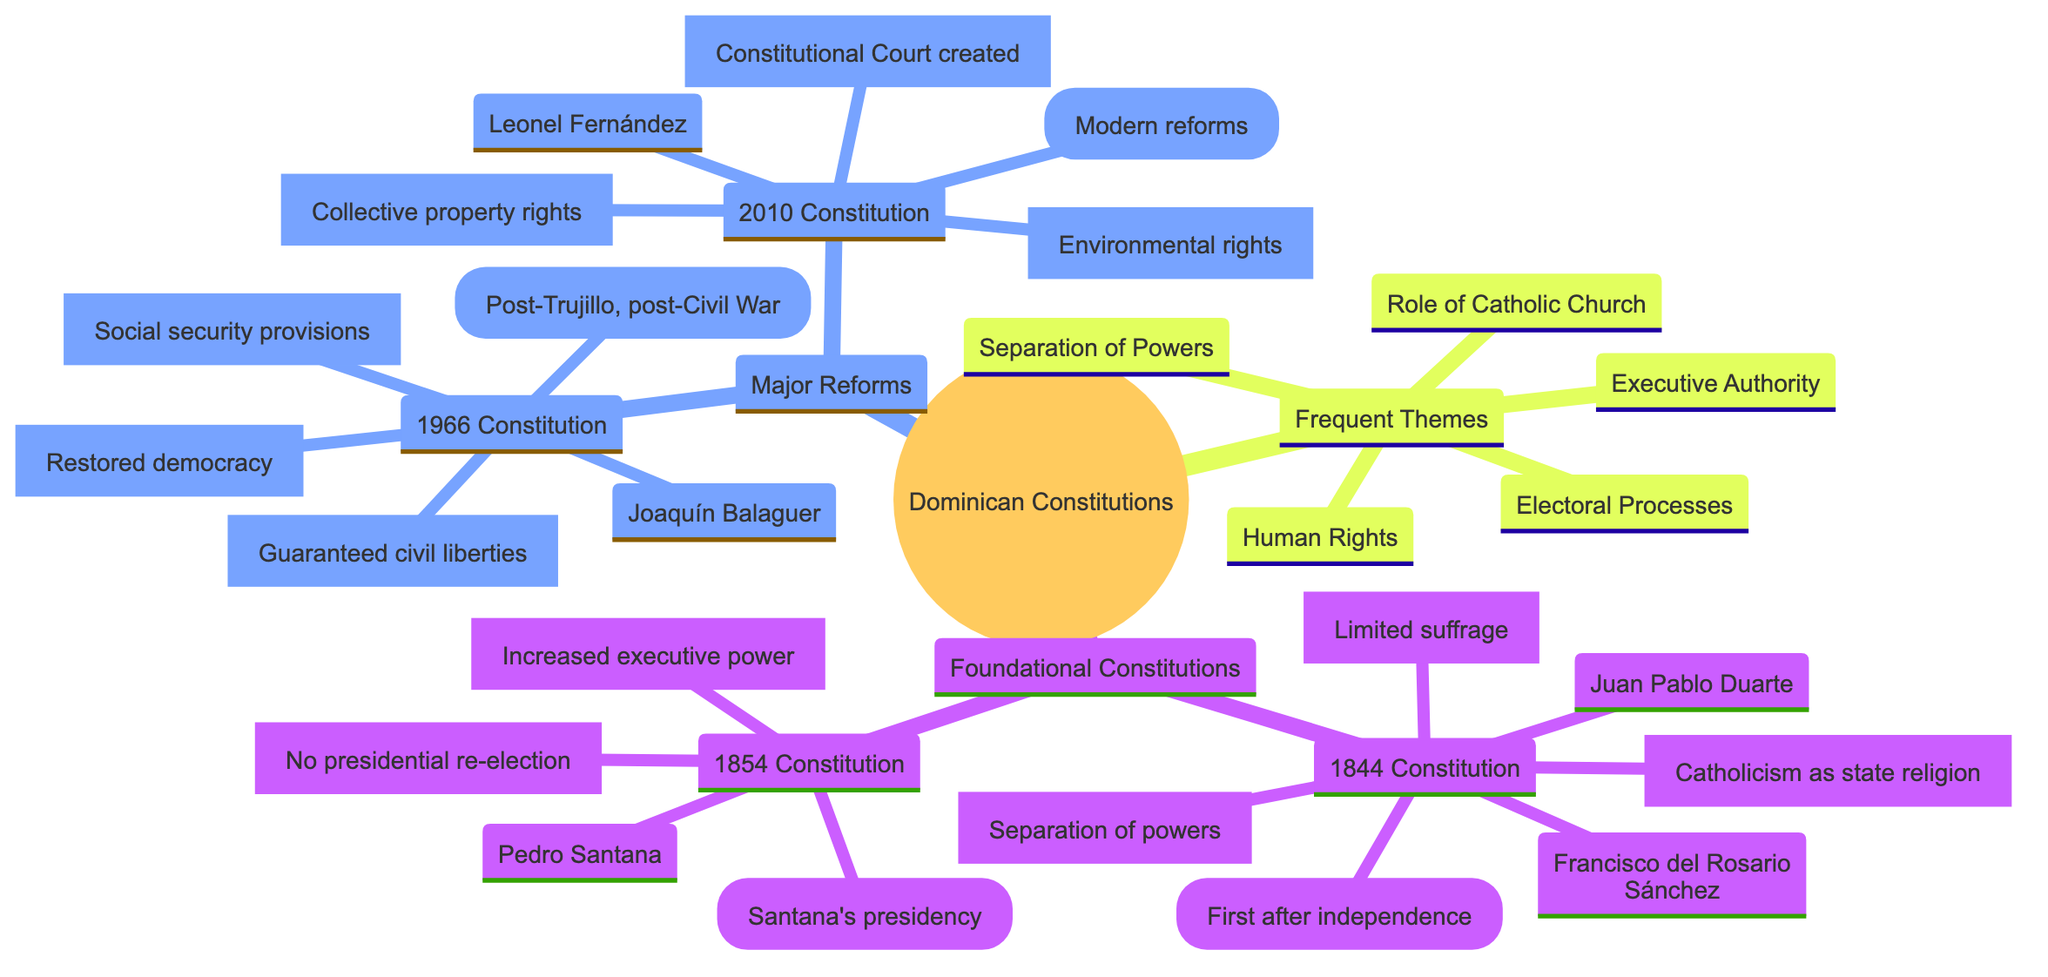What is the first constitution established after independence? The diagram indicates that the Constitution of 1844 was the first constitution after independence from Haiti, as labeled under "Foundational Constitutions."
Answer: Constitution of 1844 Who is a notable figure associated with the Constitution of 1966? Within the node for the Constitution of 1966, Joaquín Balaguer is listed as a notable figure. Therefore, he is identified with this constitution.
Answer: Joaquín Balaguer What key feature distinguishes the Constitution of 1854? Referring to the details under the Constitution of 1854, "Increased executive power" is indicated as a key feature, which sets it apart from other constitutions.
Answer: Increased executive power How many major reforms are represented in the diagram? The "Major Reforms" section of the diagram contains two nodes: the Constitution of 1966 and the Constitution of 2010, indicating that there are two major reforms depicted.
Answer: 2 What theme is shared between all constitutions listed in the diagram? The "Frequent Themes" section includes "Separation of Powers," which is a common theme across the constitutional development.
Answer: Separation of Powers Which constitution included the creation of a Constitutional Court? The Constitution of 2010 is specifically highlighted for having the key feature of the "Creation of Constitutional Court," indicating its importance in modern reforms.
Answer: Constitution of 2010 What historical context is associated with the Constitution of 1966? The diagram states that the Constitution of 1966 was established in the "Post-Trujillo era, post-Civil War (1965)," providing its historical significance.
Answer: Post-Trujillo era, post-Civil War (1965) Name one key feature of the Constitution of 1844. Under the Constitution of 1844, multiple features are listed; one of them is "Separation of powers," which is a defining characteristic of this constitution.
Answer: Separation of powers Which notable figure is linked to the Constitution of 1854? The diagram mentions Pedro Santana as the notable figure connected with the Constitution of 1854, thus identifying his role in that period.
Answer: Pedro Santana 